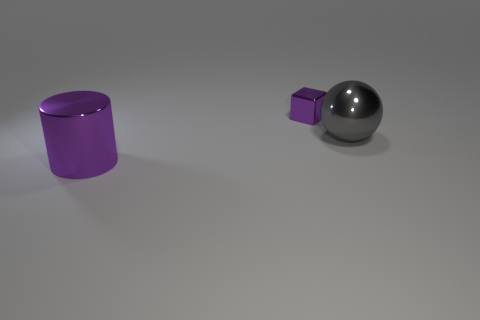Is there anything else that has the same size as the metal cube?
Offer a very short reply. No. How many objects are both left of the big ball and in front of the tiny purple shiny thing?
Make the answer very short. 1. What number of cyan things are either metal cubes or large things?
Offer a terse response. 0. There is a large metallic thing on the right side of the cylinder; does it have the same color as the tiny shiny thing behind the purple cylinder?
Offer a very short reply. No. What is the color of the thing on the right side of the object behind the shiny thing that is to the right of the purple cube?
Provide a short and direct response. Gray. There is a purple metal thing that is right of the large shiny cylinder; are there any small purple blocks to the right of it?
Make the answer very short. No. Does the tiny purple object behind the large metal sphere have the same shape as the large purple metallic object?
Provide a short and direct response. No. Is there any other thing that has the same shape as the tiny metal thing?
Your answer should be very brief. No. What number of balls are small shiny things or large purple things?
Keep it short and to the point. 0. How many tiny blue things are there?
Provide a succinct answer. 0. 